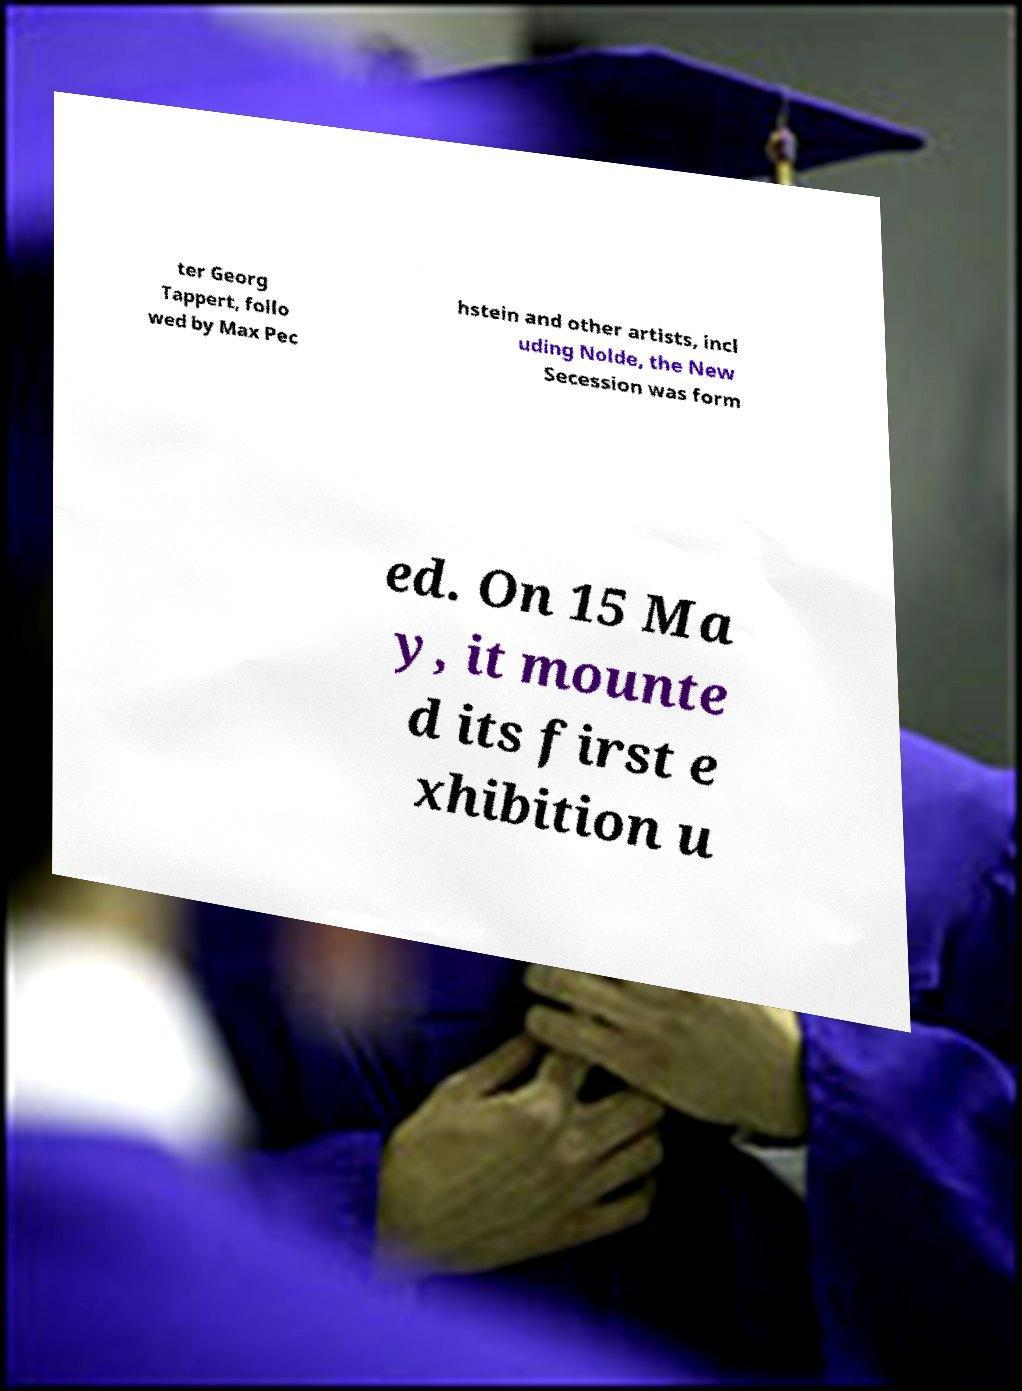Please identify and transcribe the text found in this image. ter Georg Tappert, follo wed by Max Pec hstein and other artists, incl uding Nolde, the New Secession was form ed. On 15 Ma y, it mounte d its first e xhibition u 